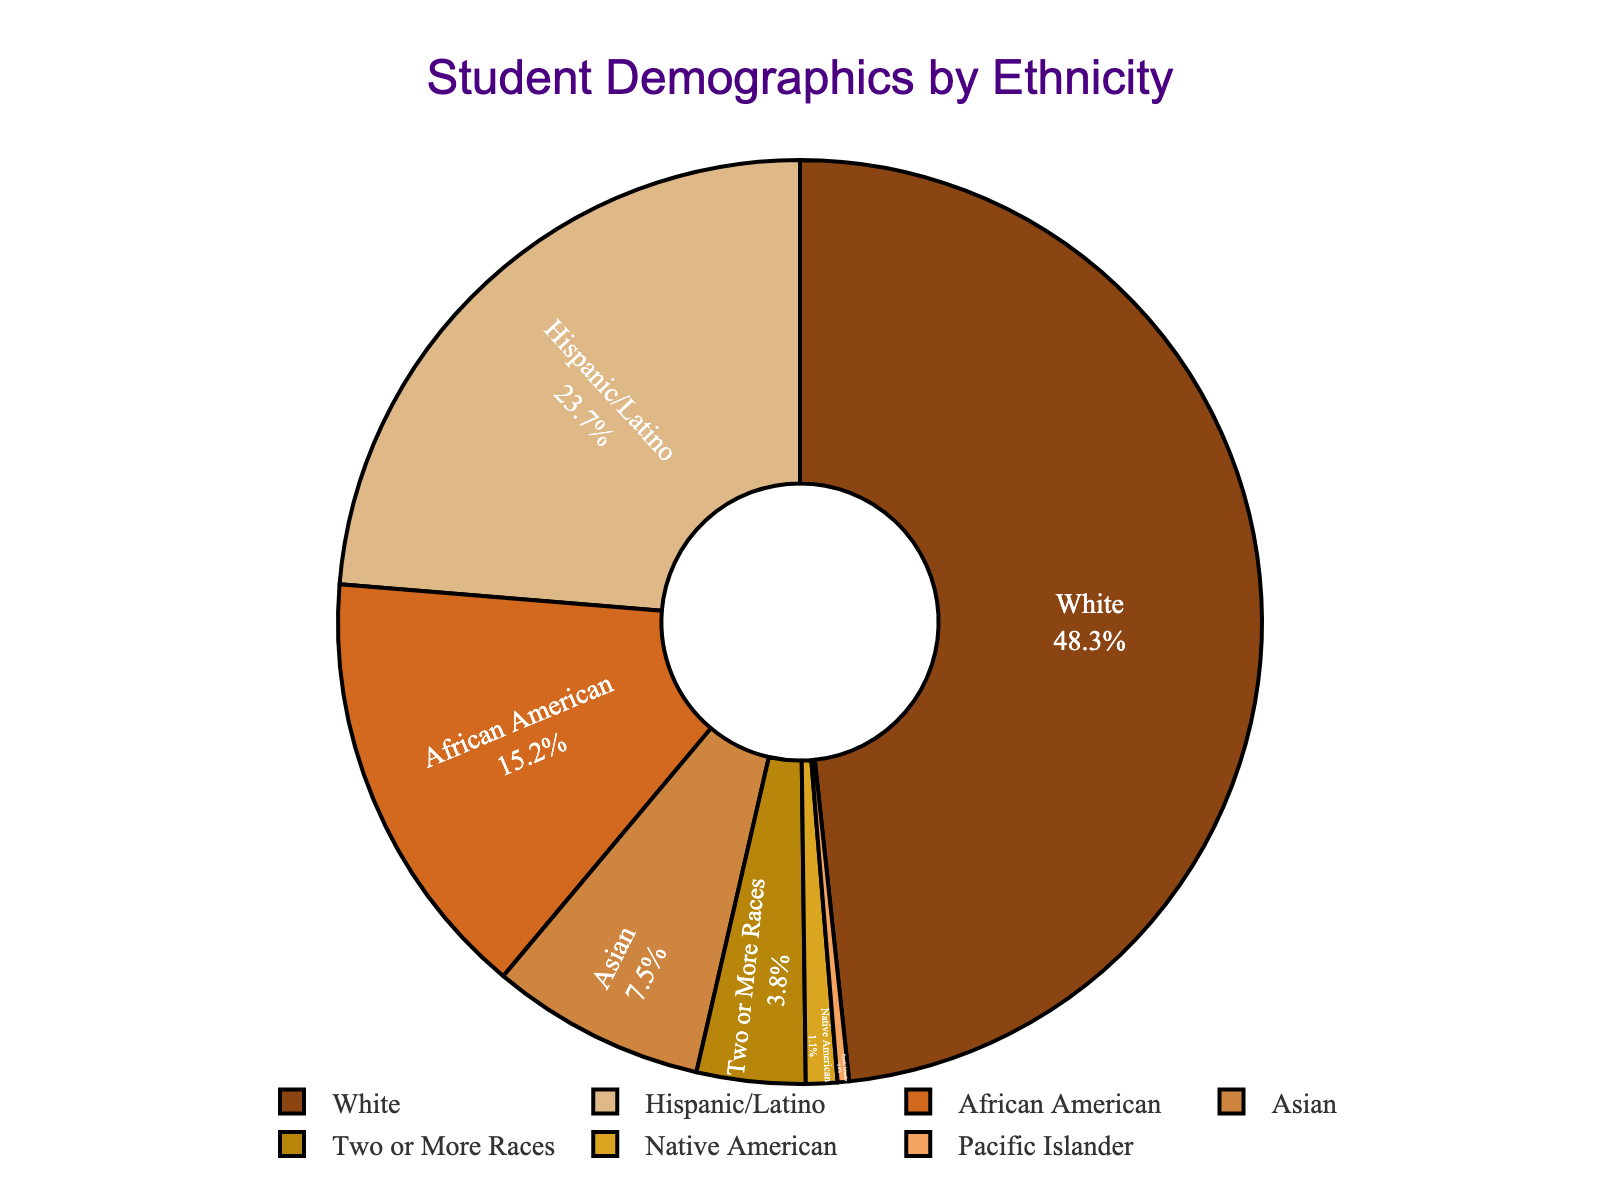What percentage of the student population is White? The figure shows the percentage values for each ethnicity segment. The White segment is labeled as 48.3%.
Answer: 48.3% How does the percentage of Hispanic/Latino students compare to the percentage of African American students? The pie chart shows that Hispanic/Latino students make up 23.7% of the population, while African American students make up 15.2%. 23.7% is greater than 15.2%.
Answer: Hispanic/Latino is greater Which ethnic group has the smallest representation in the student demographics? Observing the pie chart, the segment for Pacific Islander is the smallest with a value of 0.4%.
Answer: Pacific Islander What is the total percentage of students who are either Native American or Pacific Islander? According to the figure, Native American students make up 1.1% and Pacific Islander students make up 0.4%. Adding these together: 1.1% + 0.4% = 1.5%.
Answer: 1.5% What is the difference in the percentage of students between White and Asian ethnicities? The pie chart shows White students are 48.3% and Asian students are 7.5%. The difference is calculated as 48.3% - 7.5% = 40.8%.
Answer: 40.8% Is the combined percentage of Asian and Two or More Races students greater than the percentage of African American students? According to the chart, Asian students make up 7.5% and Two or More Races students make up 3.8%, so combined they are 7.5% + 3.8% = 11.3%. African American students make up 15.2%. 11.3% is less than 15.2%.
Answer: No What color represents Asian students in the pie chart? The segment for Asian students is shown in the middle of the chart and is colored with a lighter brown (looks like a sandy color).
Answer: Sandy brown Compare the combined percentage of Hispanic/Latino and Two or More Races students to White students. Hispanic/Latino students are 23.7% and Two or More Races are 3.8%, so combined they total 23.7% + 3.8% = 27.5%. White students are at 48.3%. 27.5% is less than 48.3%.
Answer: 48.3% is greater If Native American and Pacific Islander students were grouped together, would they form the smallest segment? The combined percentage for Native American (1.1%) and Pacific Islander (0.4%) is 1.5%. The smallest individual segment is Pacific Islander at 0.4%. 1.5% is larger than 0.4%.
Answer: No How much larger is the percentage of White students compared to the percentage of Hispanic/Latino students? The pie chart shows White students at 48.3% and Hispanic/Latino at 23.7%. The difference is calculated as 48.3% - 23.7% = 24.6%.
Answer: 24.6% 